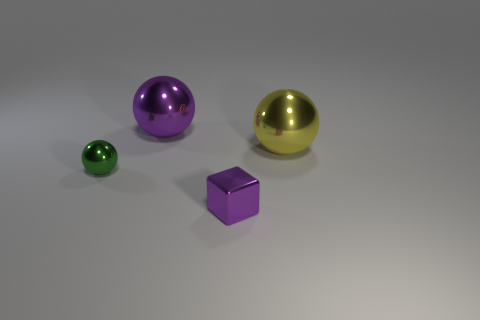There is a large object that is the same color as the tiny block; what material is it?
Keep it short and to the point. Metal. Does the object that is behind the yellow metallic object have the same material as the large yellow ball?
Your answer should be compact. Yes. There is a big sphere in front of the shiny object that is behind the big yellow thing; are there any large yellow balls that are behind it?
Make the answer very short. No. How many balls are either small blue matte things or small objects?
Provide a short and direct response. 1. What is the purple object that is right of the large purple thing made of?
Provide a short and direct response. Metal. There is a object that is the same color as the tiny cube; what size is it?
Your answer should be compact. Large. Do the large metallic ball that is to the right of the big purple metallic object and the tiny object that is left of the tiny purple thing have the same color?
Your response must be concise. No. What number of objects are either cyan metal cylinders or small metal spheres?
Your answer should be very brief. 1. How many other objects are there of the same shape as the large yellow shiny thing?
Your response must be concise. 2. Is the purple object in front of the tiny green thing made of the same material as the purple thing that is behind the tiny green metallic ball?
Make the answer very short. Yes. 